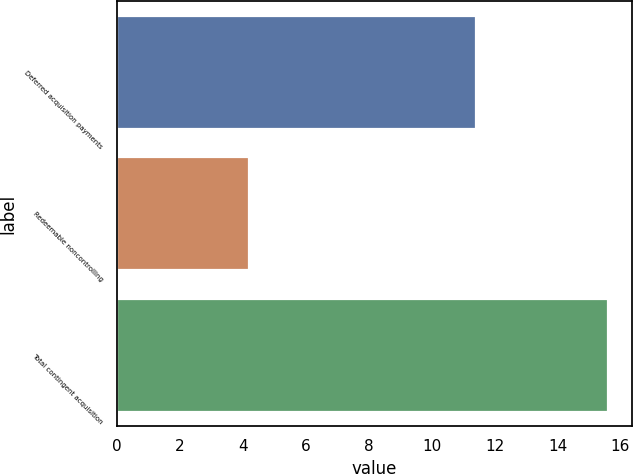Convert chart to OTSL. <chart><loc_0><loc_0><loc_500><loc_500><bar_chart><fcel>Deferred acquisition payments<fcel>Redeemable noncontrolling<fcel>Total contingent acquisition<nl><fcel>11.4<fcel>4.2<fcel>15.6<nl></chart> 